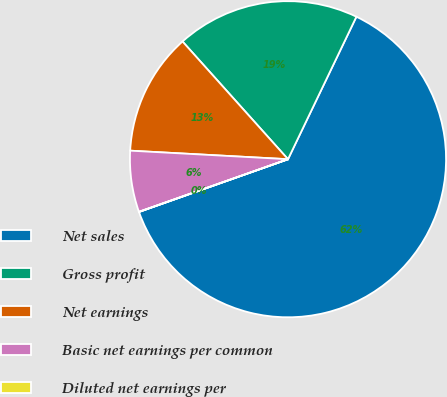Convert chart. <chart><loc_0><loc_0><loc_500><loc_500><pie_chart><fcel>Net sales<fcel>Gross profit<fcel>Net earnings<fcel>Basic net earnings per common<fcel>Diluted net earnings per<nl><fcel>62.46%<fcel>18.75%<fcel>12.51%<fcel>6.26%<fcel>0.02%<nl></chart> 